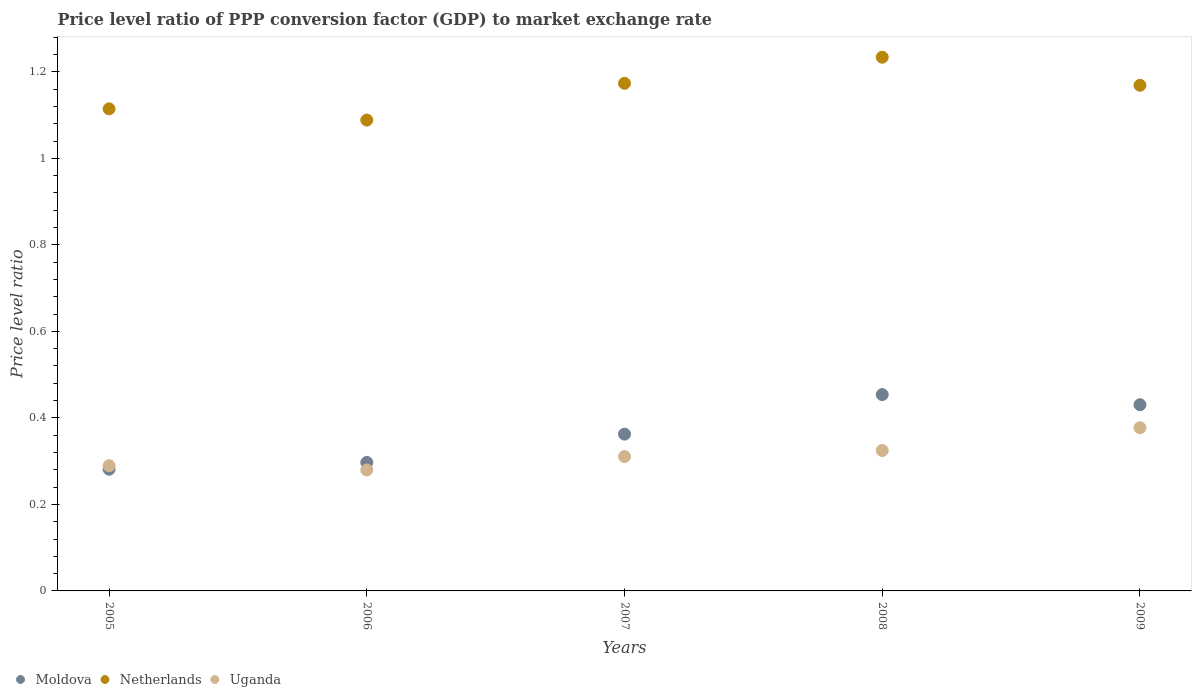What is the price level ratio in Netherlands in 2006?
Keep it short and to the point. 1.09. Across all years, what is the maximum price level ratio in Uganda?
Your answer should be very brief. 0.38. Across all years, what is the minimum price level ratio in Moldova?
Offer a very short reply. 0.28. In which year was the price level ratio in Moldova maximum?
Your answer should be very brief. 2008. In which year was the price level ratio in Uganda minimum?
Your answer should be very brief. 2006. What is the total price level ratio in Netherlands in the graph?
Keep it short and to the point. 5.78. What is the difference between the price level ratio in Netherlands in 2005 and that in 2007?
Make the answer very short. -0.06. What is the difference between the price level ratio in Uganda in 2005 and the price level ratio in Moldova in 2008?
Keep it short and to the point. -0.16. What is the average price level ratio in Moldova per year?
Your response must be concise. 0.37. In the year 2006, what is the difference between the price level ratio in Uganda and price level ratio in Moldova?
Provide a succinct answer. -0.02. What is the ratio of the price level ratio in Uganda in 2005 to that in 2007?
Your answer should be very brief. 0.93. Is the price level ratio in Moldova in 2008 less than that in 2009?
Provide a succinct answer. No. What is the difference between the highest and the second highest price level ratio in Moldova?
Provide a succinct answer. 0.02. What is the difference between the highest and the lowest price level ratio in Uganda?
Your answer should be compact. 0.1. In how many years, is the price level ratio in Netherlands greater than the average price level ratio in Netherlands taken over all years?
Ensure brevity in your answer.  3. Is the sum of the price level ratio in Uganda in 2006 and 2007 greater than the maximum price level ratio in Moldova across all years?
Provide a short and direct response. Yes. Is the price level ratio in Netherlands strictly greater than the price level ratio in Uganda over the years?
Keep it short and to the point. Yes. Is the price level ratio in Netherlands strictly less than the price level ratio in Moldova over the years?
Provide a short and direct response. No. How many dotlines are there?
Provide a succinct answer. 3. What is the difference between two consecutive major ticks on the Y-axis?
Your answer should be very brief. 0.2. Are the values on the major ticks of Y-axis written in scientific E-notation?
Provide a short and direct response. No. Does the graph contain any zero values?
Keep it short and to the point. No. Does the graph contain grids?
Give a very brief answer. No. Where does the legend appear in the graph?
Offer a terse response. Bottom left. How many legend labels are there?
Ensure brevity in your answer.  3. How are the legend labels stacked?
Provide a succinct answer. Horizontal. What is the title of the graph?
Provide a succinct answer. Price level ratio of PPP conversion factor (GDP) to market exchange rate. Does "St. Vincent and the Grenadines" appear as one of the legend labels in the graph?
Provide a succinct answer. No. What is the label or title of the X-axis?
Make the answer very short. Years. What is the label or title of the Y-axis?
Make the answer very short. Price level ratio. What is the Price level ratio of Moldova in 2005?
Make the answer very short. 0.28. What is the Price level ratio of Netherlands in 2005?
Your answer should be very brief. 1.11. What is the Price level ratio in Uganda in 2005?
Your answer should be very brief. 0.29. What is the Price level ratio of Moldova in 2006?
Provide a short and direct response. 0.3. What is the Price level ratio of Netherlands in 2006?
Provide a succinct answer. 1.09. What is the Price level ratio in Uganda in 2006?
Provide a succinct answer. 0.28. What is the Price level ratio in Moldova in 2007?
Your response must be concise. 0.36. What is the Price level ratio of Netherlands in 2007?
Provide a succinct answer. 1.17. What is the Price level ratio in Uganda in 2007?
Make the answer very short. 0.31. What is the Price level ratio of Moldova in 2008?
Provide a succinct answer. 0.45. What is the Price level ratio of Netherlands in 2008?
Offer a terse response. 1.23. What is the Price level ratio in Uganda in 2008?
Offer a terse response. 0.32. What is the Price level ratio in Moldova in 2009?
Your answer should be very brief. 0.43. What is the Price level ratio in Netherlands in 2009?
Your answer should be compact. 1.17. What is the Price level ratio in Uganda in 2009?
Make the answer very short. 0.38. Across all years, what is the maximum Price level ratio of Moldova?
Give a very brief answer. 0.45. Across all years, what is the maximum Price level ratio in Netherlands?
Keep it short and to the point. 1.23. Across all years, what is the maximum Price level ratio in Uganda?
Offer a very short reply. 0.38. Across all years, what is the minimum Price level ratio in Moldova?
Offer a terse response. 0.28. Across all years, what is the minimum Price level ratio in Netherlands?
Ensure brevity in your answer.  1.09. Across all years, what is the minimum Price level ratio of Uganda?
Offer a very short reply. 0.28. What is the total Price level ratio in Moldova in the graph?
Ensure brevity in your answer.  1.83. What is the total Price level ratio of Netherlands in the graph?
Your response must be concise. 5.78. What is the total Price level ratio in Uganda in the graph?
Keep it short and to the point. 1.58. What is the difference between the Price level ratio in Moldova in 2005 and that in 2006?
Your response must be concise. -0.02. What is the difference between the Price level ratio in Netherlands in 2005 and that in 2006?
Offer a terse response. 0.03. What is the difference between the Price level ratio of Uganda in 2005 and that in 2006?
Provide a succinct answer. 0.01. What is the difference between the Price level ratio of Moldova in 2005 and that in 2007?
Your answer should be compact. -0.08. What is the difference between the Price level ratio of Netherlands in 2005 and that in 2007?
Your response must be concise. -0.06. What is the difference between the Price level ratio in Uganda in 2005 and that in 2007?
Your answer should be compact. -0.02. What is the difference between the Price level ratio in Moldova in 2005 and that in 2008?
Your answer should be compact. -0.17. What is the difference between the Price level ratio in Netherlands in 2005 and that in 2008?
Provide a succinct answer. -0.12. What is the difference between the Price level ratio in Uganda in 2005 and that in 2008?
Offer a very short reply. -0.04. What is the difference between the Price level ratio of Moldova in 2005 and that in 2009?
Offer a terse response. -0.15. What is the difference between the Price level ratio of Netherlands in 2005 and that in 2009?
Ensure brevity in your answer.  -0.05. What is the difference between the Price level ratio in Uganda in 2005 and that in 2009?
Provide a succinct answer. -0.09. What is the difference between the Price level ratio of Moldova in 2006 and that in 2007?
Your answer should be compact. -0.07. What is the difference between the Price level ratio in Netherlands in 2006 and that in 2007?
Ensure brevity in your answer.  -0.09. What is the difference between the Price level ratio of Uganda in 2006 and that in 2007?
Keep it short and to the point. -0.03. What is the difference between the Price level ratio of Moldova in 2006 and that in 2008?
Keep it short and to the point. -0.16. What is the difference between the Price level ratio in Netherlands in 2006 and that in 2008?
Make the answer very short. -0.15. What is the difference between the Price level ratio of Uganda in 2006 and that in 2008?
Your answer should be very brief. -0.04. What is the difference between the Price level ratio of Moldova in 2006 and that in 2009?
Your answer should be compact. -0.13. What is the difference between the Price level ratio in Netherlands in 2006 and that in 2009?
Provide a succinct answer. -0.08. What is the difference between the Price level ratio in Uganda in 2006 and that in 2009?
Give a very brief answer. -0.1. What is the difference between the Price level ratio in Moldova in 2007 and that in 2008?
Your answer should be very brief. -0.09. What is the difference between the Price level ratio in Netherlands in 2007 and that in 2008?
Offer a terse response. -0.06. What is the difference between the Price level ratio of Uganda in 2007 and that in 2008?
Offer a terse response. -0.01. What is the difference between the Price level ratio in Moldova in 2007 and that in 2009?
Provide a short and direct response. -0.07. What is the difference between the Price level ratio of Netherlands in 2007 and that in 2009?
Your answer should be very brief. 0. What is the difference between the Price level ratio of Uganda in 2007 and that in 2009?
Make the answer very short. -0.07. What is the difference between the Price level ratio of Moldova in 2008 and that in 2009?
Ensure brevity in your answer.  0.02. What is the difference between the Price level ratio of Netherlands in 2008 and that in 2009?
Provide a succinct answer. 0.06. What is the difference between the Price level ratio in Uganda in 2008 and that in 2009?
Ensure brevity in your answer.  -0.05. What is the difference between the Price level ratio in Moldova in 2005 and the Price level ratio in Netherlands in 2006?
Keep it short and to the point. -0.81. What is the difference between the Price level ratio of Moldova in 2005 and the Price level ratio of Uganda in 2006?
Ensure brevity in your answer.  0. What is the difference between the Price level ratio in Netherlands in 2005 and the Price level ratio in Uganda in 2006?
Your answer should be very brief. 0.83. What is the difference between the Price level ratio of Moldova in 2005 and the Price level ratio of Netherlands in 2007?
Keep it short and to the point. -0.89. What is the difference between the Price level ratio of Moldova in 2005 and the Price level ratio of Uganda in 2007?
Provide a succinct answer. -0.03. What is the difference between the Price level ratio in Netherlands in 2005 and the Price level ratio in Uganda in 2007?
Keep it short and to the point. 0.8. What is the difference between the Price level ratio in Moldova in 2005 and the Price level ratio in Netherlands in 2008?
Offer a very short reply. -0.95. What is the difference between the Price level ratio in Moldova in 2005 and the Price level ratio in Uganda in 2008?
Make the answer very short. -0.04. What is the difference between the Price level ratio of Netherlands in 2005 and the Price level ratio of Uganda in 2008?
Your response must be concise. 0.79. What is the difference between the Price level ratio of Moldova in 2005 and the Price level ratio of Netherlands in 2009?
Make the answer very short. -0.89. What is the difference between the Price level ratio in Moldova in 2005 and the Price level ratio in Uganda in 2009?
Provide a short and direct response. -0.1. What is the difference between the Price level ratio in Netherlands in 2005 and the Price level ratio in Uganda in 2009?
Provide a short and direct response. 0.74. What is the difference between the Price level ratio of Moldova in 2006 and the Price level ratio of Netherlands in 2007?
Offer a very short reply. -0.88. What is the difference between the Price level ratio in Moldova in 2006 and the Price level ratio in Uganda in 2007?
Provide a short and direct response. -0.01. What is the difference between the Price level ratio in Netherlands in 2006 and the Price level ratio in Uganda in 2007?
Make the answer very short. 0.78. What is the difference between the Price level ratio of Moldova in 2006 and the Price level ratio of Netherlands in 2008?
Give a very brief answer. -0.94. What is the difference between the Price level ratio of Moldova in 2006 and the Price level ratio of Uganda in 2008?
Offer a terse response. -0.03. What is the difference between the Price level ratio in Netherlands in 2006 and the Price level ratio in Uganda in 2008?
Offer a terse response. 0.76. What is the difference between the Price level ratio of Moldova in 2006 and the Price level ratio of Netherlands in 2009?
Make the answer very short. -0.87. What is the difference between the Price level ratio in Moldova in 2006 and the Price level ratio in Uganda in 2009?
Ensure brevity in your answer.  -0.08. What is the difference between the Price level ratio of Netherlands in 2006 and the Price level ratio of Uganda in 2009?
Your answer should be compact. 0.71. What is the difference between the Price level ratio in Moldova in 2007 and the Price level ratio in Netherlands in 2008?
Your answer should be very brief. -0.87. What is the difference between the Price level ratio in Moldova in 2007 and the Price level ratio in Uganda in 2008?
Offer a very short reply. 0.04. What is the difference between the Price level ratio of Netherlands in 2007 and the Price level ratio of Uganda in 2008?
Offer a terse response. 0.85. What is the difference between the Price level ratio in Moldova in 2007 and the Price level ratio in Netherlands in 2009?
Your answer should be compact. -0.81. What is the difference between the Price level ratio in Moldova in 2007 and the Price level ratio in Uganda in 2009?
Provide a succinct answer. -0.01. What is the difference between the Price level ratio in Netherlands in 2007 and the Price level ratio in Uganda in 2009?
Provide a succinct answer. 0.8. What is the difference between the Price level ratio of Moldova in 2008 and the Price level ratio of Netherlands in 2009?
Your answer should be compact. -0.71. What is the difference between the Price level ratio in Moldova in 2008 and the Price level ratio in Uganda in 2009?
Make the answer very short. 0.08. What is the difference between the Price level ratio in Netherlands in 2008 and the Price level ratio in Uganda in 2009?
Offer a very short reply. 0.86. What is the average Price level ratio in Moldova per year?
Your response must be concise. 0.36. What is the average Price level ratio in Netherlands per year?
Give a very brief answer. 1.16. What is the average Price level ratio of Uganda per year?
Offer a very short reply. 0.32. In the year 2005, what is the difference between the Price level ratio in Moldova and Price level ratio in Netherlands?
Provide a short and direct response. -0.83. In the year 2005, what is the difference between the Price level ratio in Moldova and Price level ratio in Uganda?
Provide a short and direct response. -0.01. In the year 2005, what is the difference between the Price level ratio of Netherlands and Price level ratio of Uganda?
Give a very brief answer. 0.82. In the year 2006, what is the difference between the Price level ratio in Moldova and Price level ratio in Netherlands?
Your response must be concise. -0.79. In the year 2006, what is the difference between the Price level ratio in Moldova and Price level ratio in Uganda?
Your answer should be very brief. 0.02. In the year 2006, what is the difference between the Price level ratio in Netherlands and Price level ratio in Uganda?
Offer a terse response. 0.81. In the year 2007, what is the difference between the Price level ratio in Moldova and Price level ratio in Netherlands?
Offer a very short reply. -0.81. In the year 2007, what is the difference between the Price level ratio of Moldova and Price level ratio of Uganda?
Give a very brief answer. 0.05. In the year 2007, what is the difference between the Price level ratio in Netherlands and Price level ratio in Uganda?
Your response must be concise. 0.86. In the year 2008, what is the difference between the Price level ratio of Moldova and Price level ratio of Netherlands?
Your response must be concise. -0.78. In the year 2008, what is the difference between the Price level ratio in Moldova and Price level ratio in Uganda?
Provide a succinct answer. 0.13. In the year 2008, what is the difference between the Price level ratio in Netherlands and Price level ratio in Uganda?
Provide a short and direct response. 0.91. In the year 2009, what is the difference between the Price level ratio of Moldova and Price level ratio of Netherlands?
Keep it short and to the point. -0.74. In the year 2009, what is the difference between the Price level ratio in Moldova and Price level ratio in Uganda?
Provide a short and direct response. 0.05. In the year 2009, what is the difference between the Price level ratio of Netherlands and Price level ratio of Uganda?
Your answer should be very brief. 0.79. What is the ratio of the Price level ratio of Moldova in 2005 to that in 2006?
Your answer should be very brief. 0.95. What is the ratio of the Price level ratio of Netherlands in 2005 to that in 2006?
Ensure brevity in your answer.  1.02. What is the ratio of the Price level ratio of Uganda in 2005 to that in 2006?
Keep it short and to the point. 1.04. What is the ratio of the Price level ratio in Moldova in 2005 to that in 2007?
Offer a very short reply. 0.78. What is the ratio of the Price level ratio of Netherlands in 2005 to that in 2007?
Provide a short and direct response. 0.95. What is the ratio of the Price level ratio of Uganda in 2005 to that in 2007?
Your response must be concise. 0.93. What is the ratio of the Price level ratio in Moldova in 2005 to that in 2008?
Keep it short and to the point. 0.62. What is the ratio of the Price level ratio in Netherlands in 2005 to that in 2008?
Your answer should be very brief. 0.9. What is the ratio of the Price level ratio of Uganda in 2005 to that in 2008?
Offer a very short reply. 0.89. What is the ratio of the Price level ratio of Moldova in 2005 to that in 2009?
Ensure brevity in your answer.  0.65. What is the ratio of the Price level ratio in Netherlands in 2005 to that in 2009?
Give a very brief answer. 0.95. What is the ratio of the Price level ratio of Uganda in 2005 to that in 2009?
Ensure brevity in your answer.  0.77. What is the ratio of the Price level ratio of Moldova in 2006 to that in 2007?
Your answer should be very brief. 0.82. What is the ratio of the Price level ratio in Netherlands in 2006 to that in 2007?
Keep it short and to the point. 0.93. What is the ratio of the Price level ratio of Uganda in 2006 to that in 2007?
Offer a terse response. 0.9. What is the ratio of the Price level ratio of Moldova in 2006 to that in 2008?
Keep it short and to the point. 0.65. What is the ratio of the Price level ratio of Netherlands in 2006 to that in 2008?
Give a very brief answer. 0.88. What is the ratio of the Price level ratio in Uganda in 2006 to that in 2008?
Offer a terse response. 0.86. What is the ratio of the Price level ratio of Moldova in 2006 to that in 2009?
Your answer should be compact. 0.69. What is the ratio of the Price level ratio of Netherlands in 2006 to that in 2009?
Make the answer very short. 0.93. What is the ratio of the Price level ratio of Uganda in 2006 to that in 2009?
Your answer should be very brief. 0.74. What is the ratio of the Price level ratio of Moldova in 2007 to that in 2008?
Provide a succinct answer. 0.8. What is the ratio of the Price level ratio of Netherlands in 2007 to that in 2008?
Your answer should be compact. 0.95. What is the ratio of the Price level ratio in Uganda in 2007 to that in 2008?
Make the answer very short. 0.96. What is the ratio of the Price level ratio of Moldova in 2007 to that in 2009?
Ensure brevity in your answer.  0.84. What is the ratio of the Price level ratio in Uganda in 2007 to that in 2009?
Give a very brief answer. 0.82. What is the ratio of the Price level ratio of Moldova in 2008 to that in 2009?
Your response must be concise. 1.05. What is the ratio of the Price level ratio of Netherlands in 2008 to that in 2009?
Give a very brief answer. 1.06. What is the ratio of the Price level ratio in Uganda in 2008 to that in 2009?
Your answer should be very brief. 0.86. What is the difference between the highest and the second highest Price level ratio of Moldova?
Your response must be concise. 0.02. What is the difference between the highest and the second highest Price level ratio in Netherlands?
Provide a succinct answer. 0.06. What is the difference between the highest and the second highest Price level ratio in Uganda?
Provide a succinct answer. 0.05. What is the difference between the highest and the lowest Price level ratio of Moldova?
Offer a terse response. 0.17. What is the difference between the highest and the lowest Price level ratio of Netherlands?
Your response must be concise. 0.15. What is the difference between the highest and the lowest Price level ratio in Uganda?
Keep it short and to the point. 0.1. 